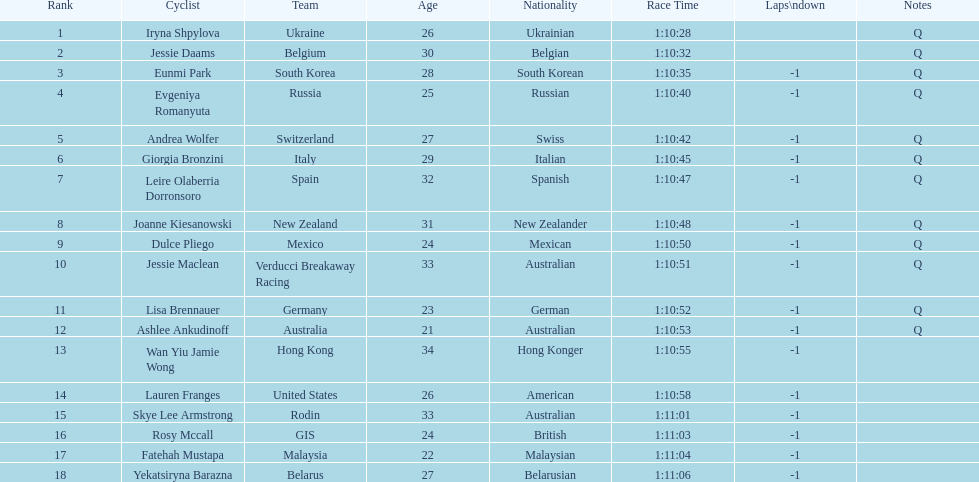How many consecutive notes are there? 12. 